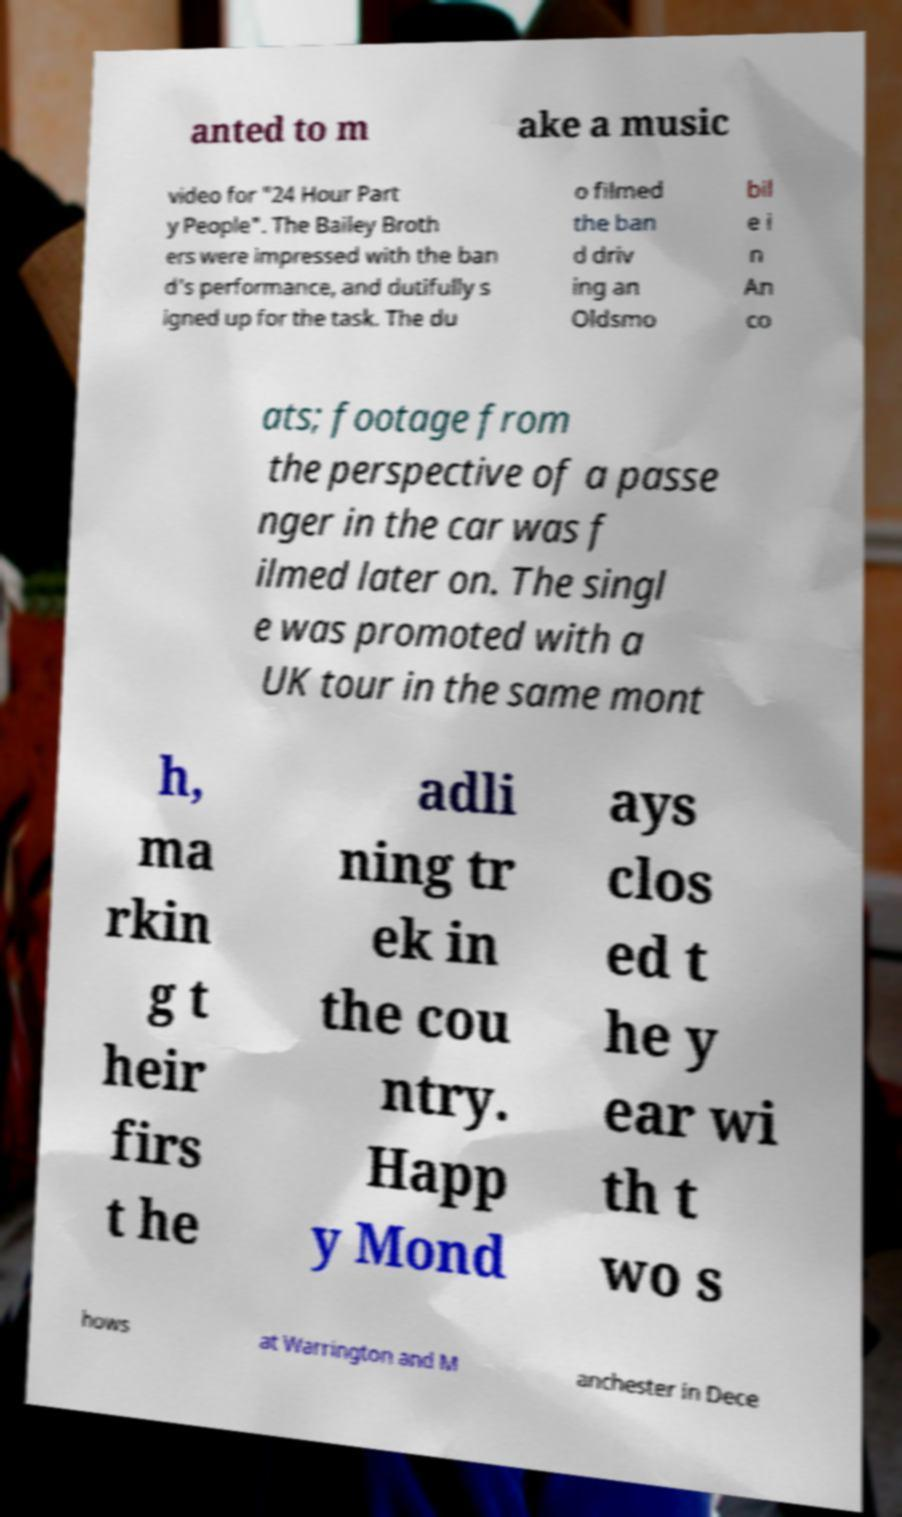Can you read and provide the text displayed in the image?This photo seems to have some interesting text. Can you extract and type it out for me? anted to m ake a music video for "24 Hour Part y People". The Bailey Broth ers were impressed with the ban d's performance, and dutifully s igned up for the task. The du o filmed the ban d driv ing an Oldsmo bil e i n An co ats; footage from the perspective of a passe nger in the car was f ilmed later on. The singl e was promoted with a UK tour in the same mont h, ma rkin g t heir firs t he adli ning tr ek in the cou ntry. Happ y Mond ays clos ed t he y ear wi th t wo s hows at Warrington and M anchester in Dece 